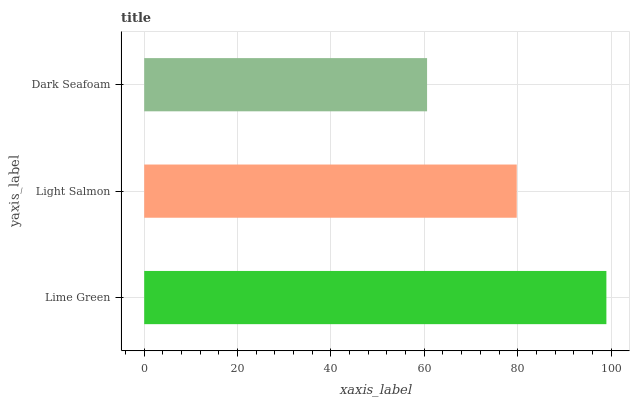Is Dark Seafoam the minimum?
Answer yes or no. Yes. Is Lime Green the maximum?
Answer yes or no. Yes. Is Light Salmon the minimum?
Answer yes or no. No. Is Light Salmon the maximum?
Answer yes or no. No. Is Lime Green greater than Light Salmon?
Answer yes or no. Yes. Is Light Salmon less than Lime Green?
Answer yes or no. Yes. Is Light Salmon greater than Lime Green?
Answer yes or no. No. Is Lime Green less than Light Salmon?
Answer yes or no. No. Is Light Salmon the high median?
Answer yes or no. Yes. Is Light Salmon the low median?
Answer yes or no. Yes. Is Dark Seafoam the high median?
Answer yes or no. No. Is Dark Seafoam the low median?
Answer yes or no. No. 